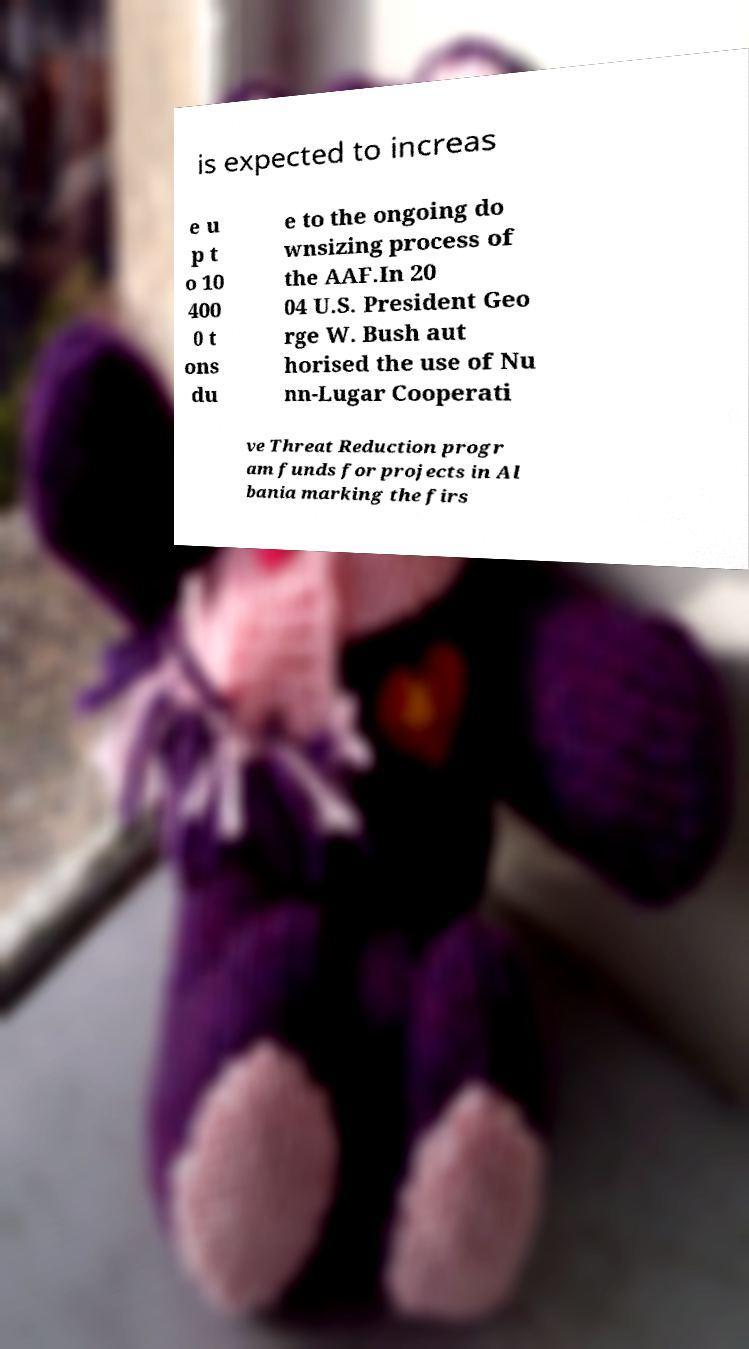I need the written content from this picture converted into text. Can you do that? is expected to increas e u p t o 10 400 0 t ons du e to the ongoing do wnsizing process of the AAF.In 20 04 U.S. President Geo rge W. Bush aut horised the use of Nu nn-Lugar Cooperati ve Threat Reduction progr am funds for projects in Al bania marking the firs 